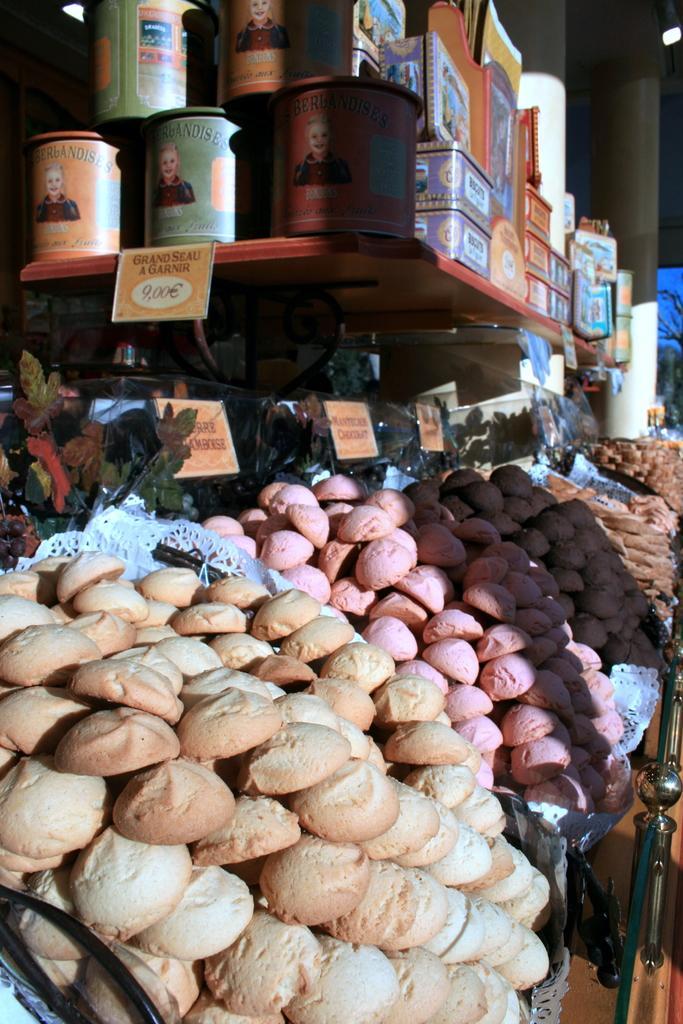Could you give a brief overview of what you see in this image? In this image we can see a food item, at the top there are tins, boxes on a wooden table, there are tags, there is a light. 